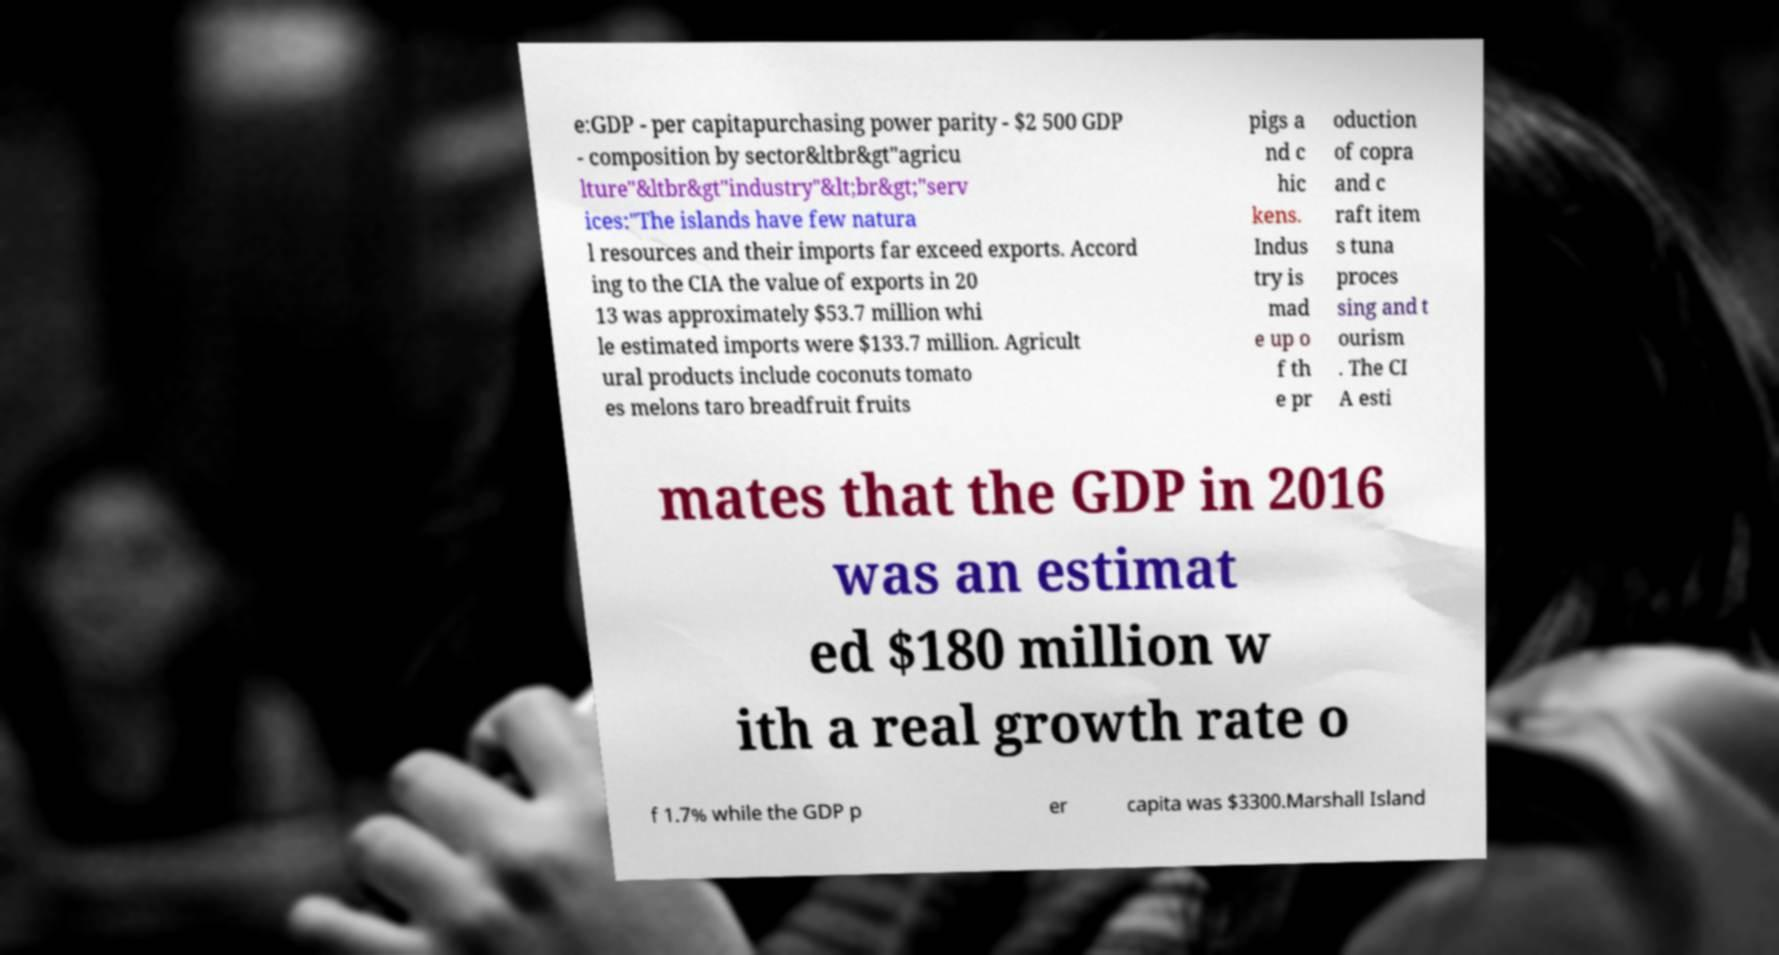What messages or text are displayed in this image? I need them in a readable, typed format. e:GDP - per capitapurchasing power parity - $2 500 GDP - composition by sector&ltbr&gt"agricu lture"&ltbr&gt"industry"&lt;br&gt;"serv ices:"The islands have few natura l resources and their imports far exceed exports. Accord ing to the CIA the value of exports in 20 13 was approximately $53.7 million whi le estimated imports were $133.7 million. Agricult ural products include coconuts tomato es melons taro breadfruit fruits pigs a nd c hic kens. Indus try is mad e up o f th e pr oduction of copra and c raft item s tuna proces sing and t ourism . The CI A esti mates that the GDP in 2016 was an estimat ed $180 million w ith a real growth rate o f 1.7% while the GDP p er capita was $3300.Marshall Island 